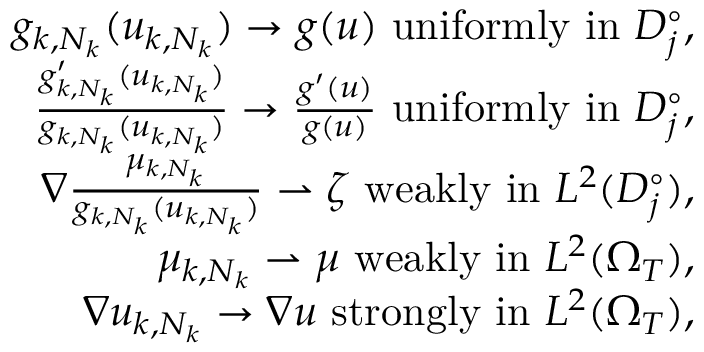<formula> <loc_0><loc_0><loc_500><loc_500>\begin{array} { r l r } & { g _ { k , N _ { k } } ( u _ { k , N _ { k } } ) \rightarrow g ( u ) u n i f o r m l y i n D _ { j } ^ { \circ } , } \\ & { \frac { g _ { k , N _ { k } } ^ { \prime } ( u _ { k , N _ { k } } ) } { g _ { k , N _ { k } } ( u _ { k , N _ { k } } ) } \rightarrow \frac { g ^ { \prime } ( u ) } { g ( u ) } u n i f o r m l y i n D _ { j } ^ { \circ } , } \\ & { \nabla \frac { \mu _ { k , N _ { k } } } { g _ { k , N _ { k } } ( u _ { k , N _ { k } } ) } \rightharpoonup \zeta w e a k l y i n L ^ { 2 } ( D _ { j } ^ { \circ } ) , } \\ & { \mu _ { k , N _ { k } } \rightharpoonup \mu w e a k l y i n L ^ { 2 } ( \Omega _ { T } ) , } \\ & { \nabla u _ { k , N _ { k } } \rightarrow \nabla u s t r o n g l y i n L ^ { 2 } ( \Omega _ { T } ) , } \end{array}</formula> 